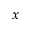<formula> <loc_0><loc_0><loc_500><loc_500>x</formula> 